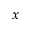<formula> <loc_0><loc_0><loc_500><loc_500>x</formula> 